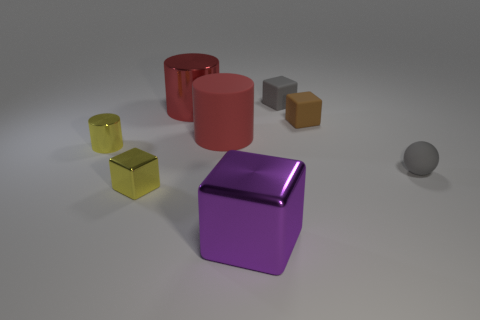There is a small cube that is to the left of the small gray matte object behind the shiny object that is behind the yellow cylinder; what color is it?
Offer a terse response. Yellow. What is the color of the metallic cylinder that is the same size as the yellow shiny cube?
Offer a very short reply. Yellow. There is a yellow metallic object behind the tiny ball in front of the small gray rubber object that is left of the tiny brown object; what is its shape?
Offer a very short reply. Cylinder. What shape is the small thing that is the same color as the tiny ball?
Give a very brief answer. Cube. What number of objects are tiny cylinders or red cylinders behind the tiny cylinder?
Make the answer very short. 3. There is a gray matte object to the left of the ball; is its size the same as the yellow block?
Keep it short and to the point. Yes. There is a large object in front of the tiny yellow block; what is it made of?
Your answer should be compact. Metal. Are there an equal number of small gray things that are on the left side of the tiny metallic cube and cylinders on the right side of the tiny yellow shiny cylinder?
Your response must be concise. No. There is another metal object that is the same shape as the large red metallic thing; what is its color?
Your response must be concise. Yellow. Is there any other thing that is the same color as the large cube?
Keep it short and to the point. No. 